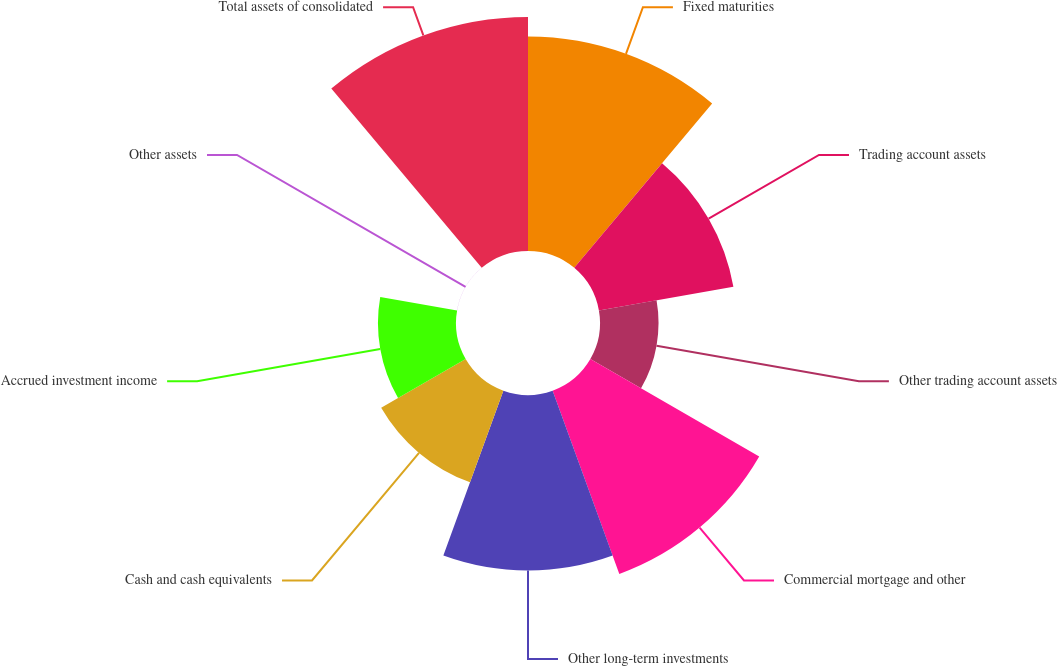Convert chart to OTSL. <chart><loc_0><loc_0><loc_500><loc_500><pie_chart><fcel>Fixed maturities<fcel>Trading account assets<fcel>Other trading account assets<fcel>Commercial mortgage and other<fcel>Other long-term investments<fcel>Cash and cash equivalents<fcel>Accrued investment income<fcel>Other assets<fcel>Total assets of consolidated<nl><fcel>18.03%<fcel>11.48%<fcel>4.92%<fcel>16.39%<fcel>14.75%<fcel>8.2%<fcel>6.56%<fcel>0.01%<fcel>19.67%<nl></chart> 